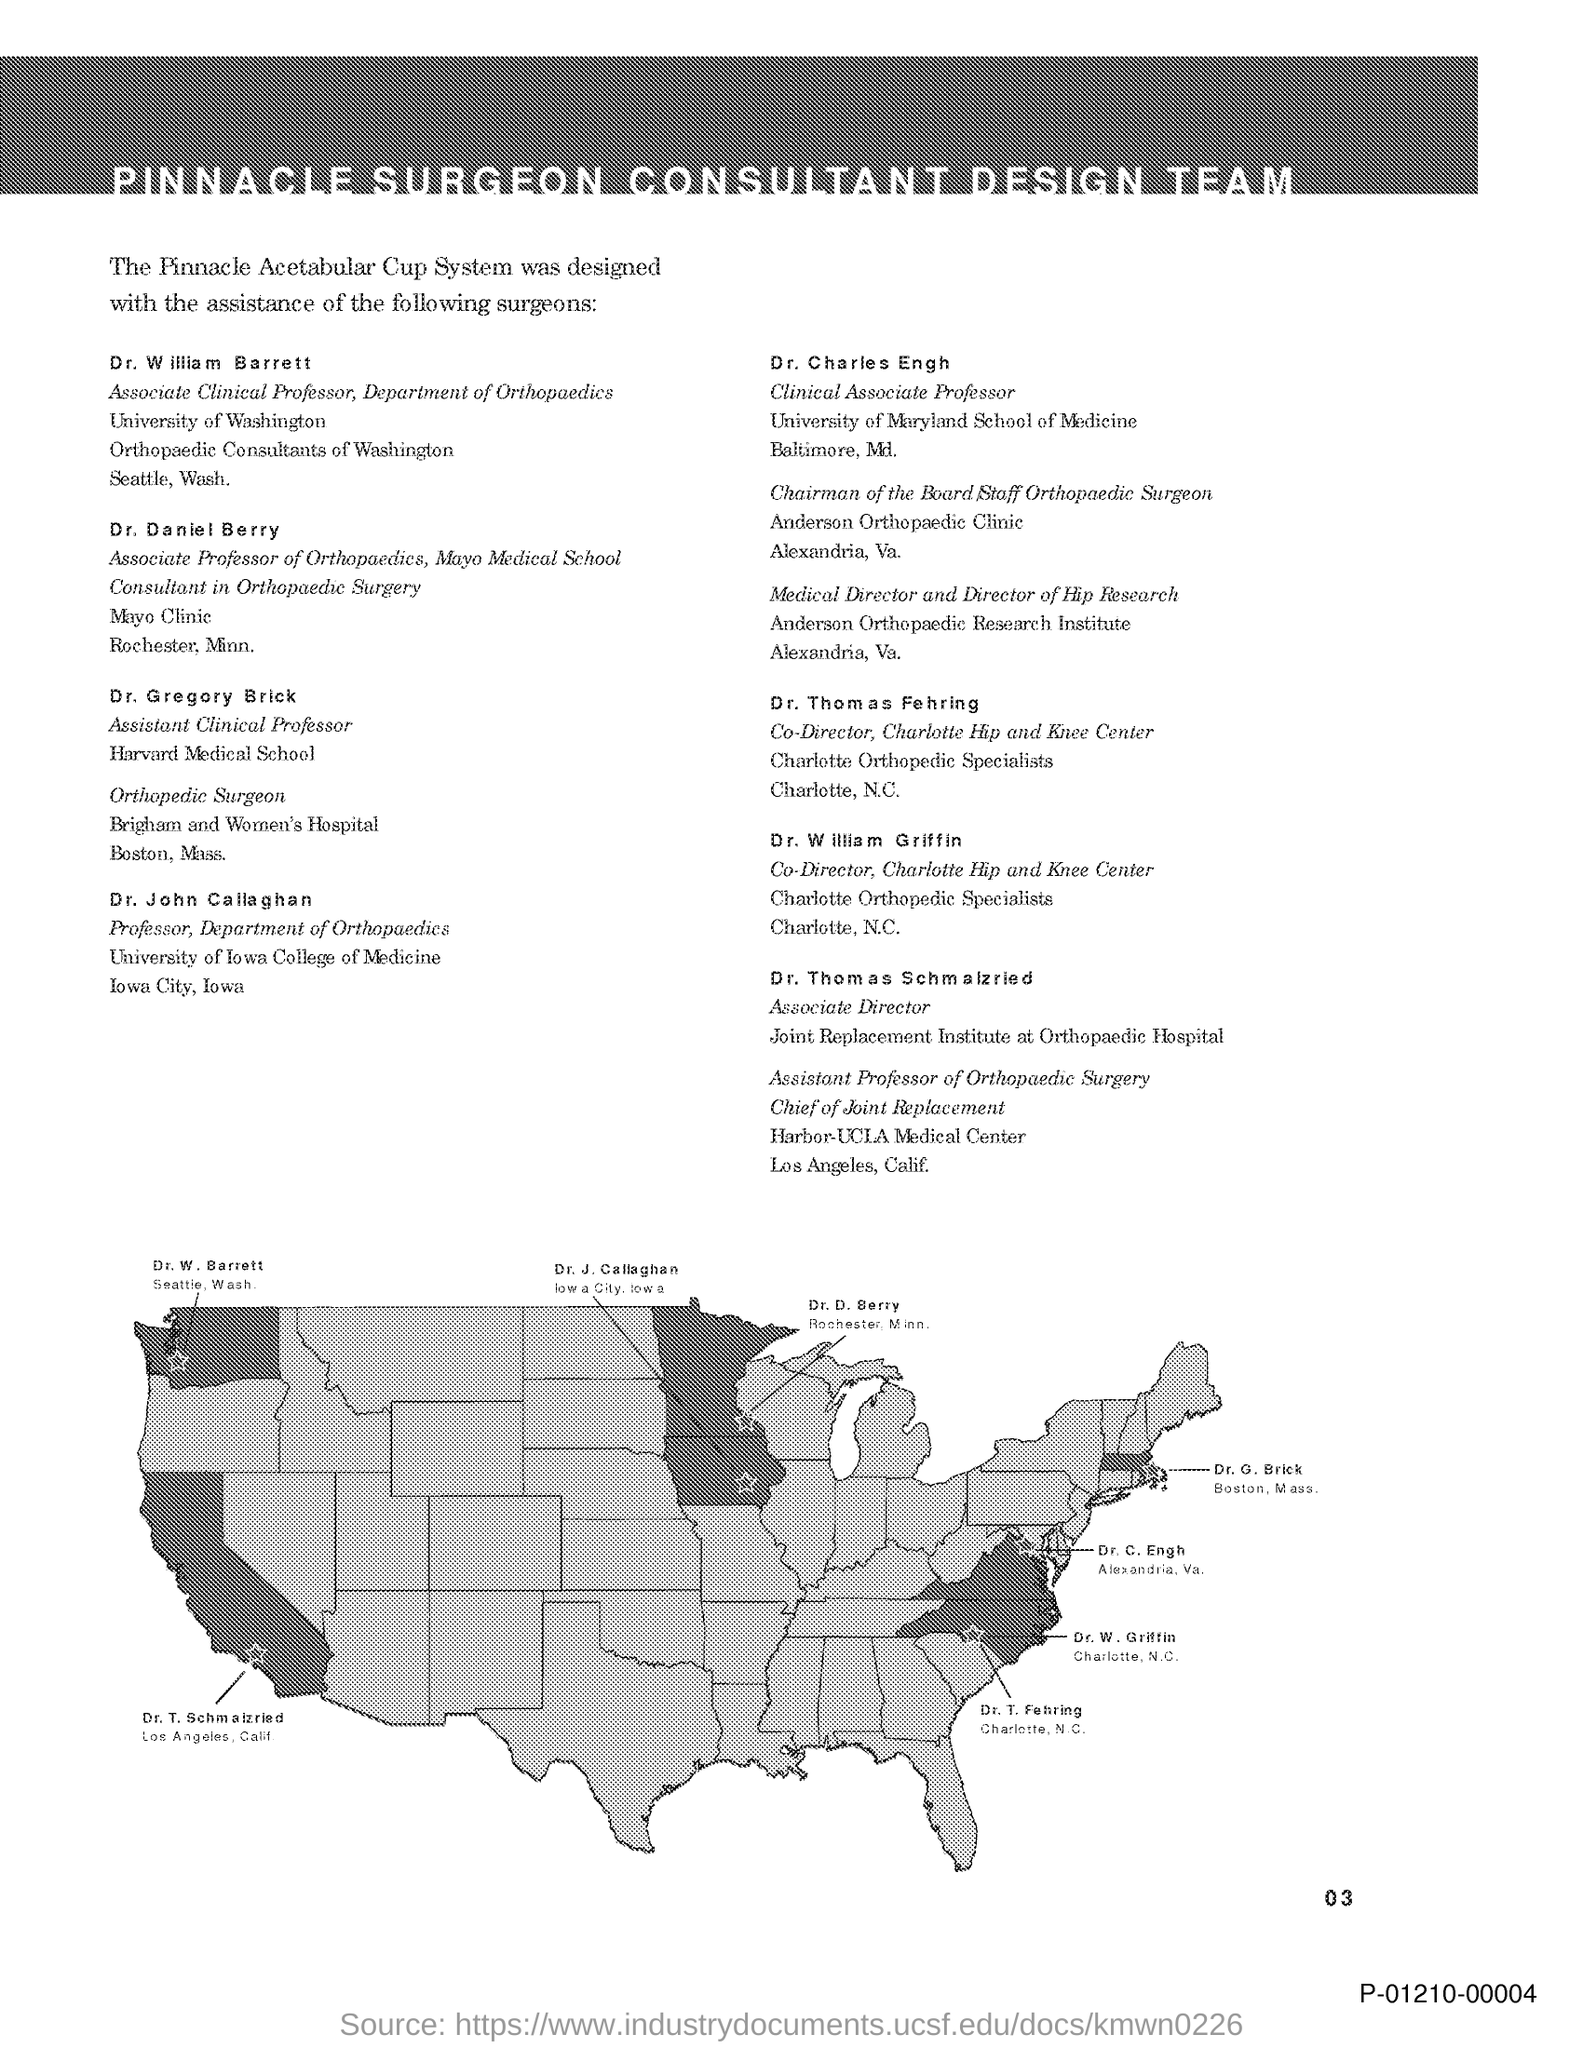Outline some significant characteristics in this image. Dr. John Callaghan holds the designation of Professor in the Department of Orthopaedics. Dr. William Barnett holds the designation of Associate Clinical Professor in the Department of Orthopaedics. The title of this document is Pinnacle Surgeon Consultant Design Team. 